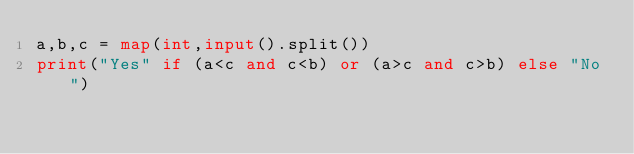<code> <loc_0><loc_0><loc_500><loc_500><_Python_>a,b,c = map(int,input().split())
print("Yes" if (a<c and c<b) or (a>c and c>b) else "No")</code> 